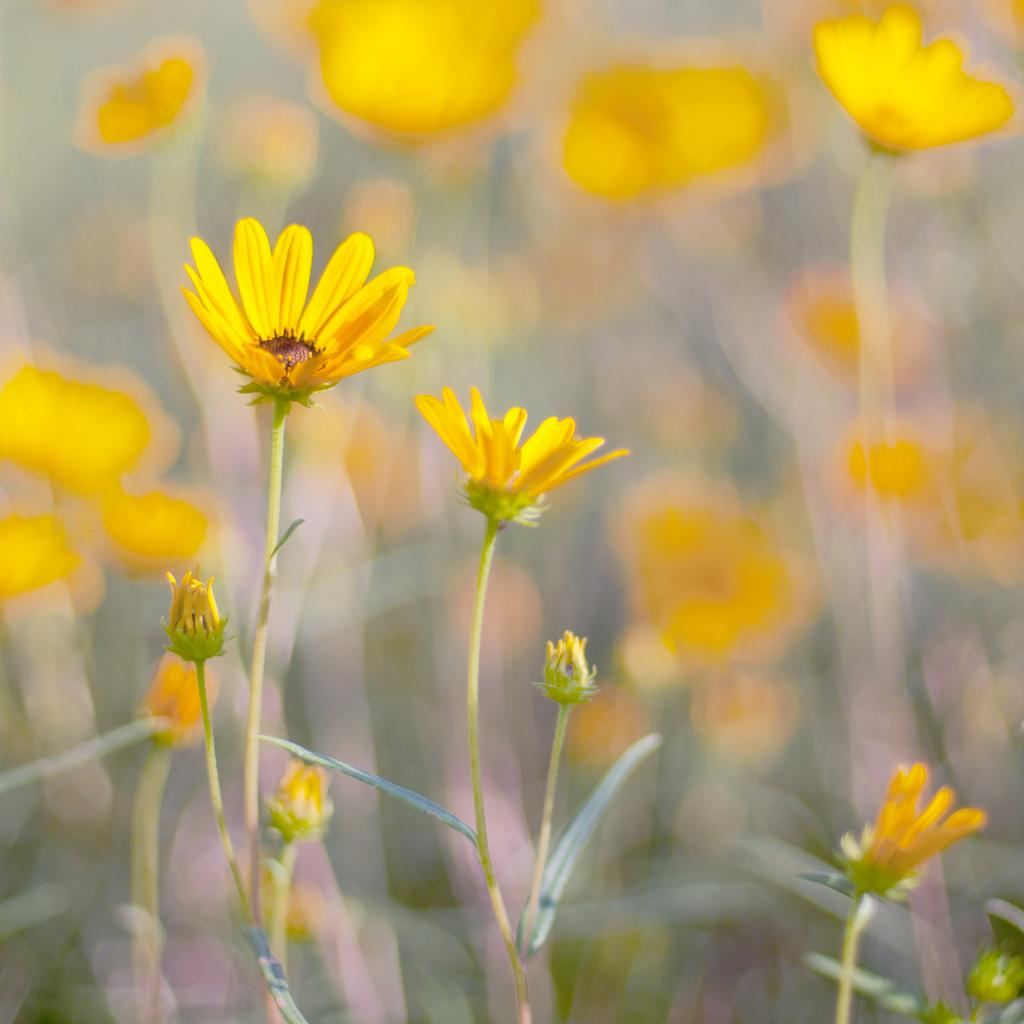What type of plant life is visible in the image? There are flowers, flower buds, and leaves in the image. Can you describe the different stages of growth depicted in the image? The image shows flowers in full bloom as well as flower buds, which are still in the process of growing. What other parts of the plants can be seen in the image? Leaves are also visible in the image. How many bees can be seen buzzing around the flowers in the image? There are no bees present in the image; it only features flowers, flower buds, and leaves. 